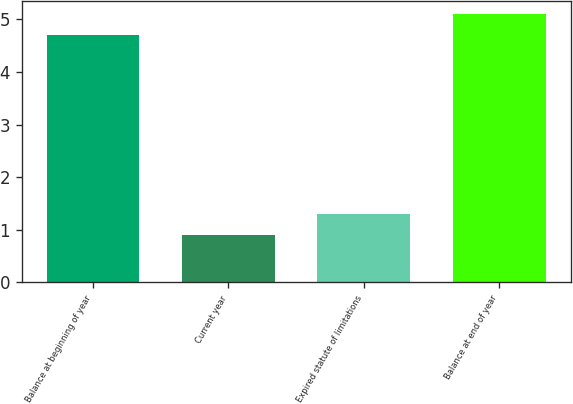<chart> <loc_0><loc_0><loc_500><loc_500><bar_chart><fcel>Balance at beginning of year<fcel>Current year<fcel>Expired statute of limitations<fcel>Balance at end of year<nl><fcel>4.7<fcel>0.9<fcel>1.3<fcel>5.1<nl></chart> 